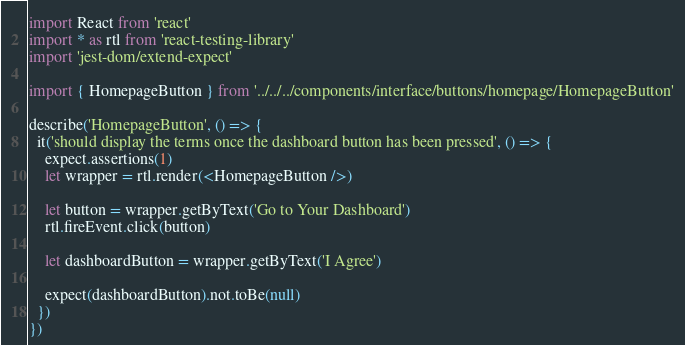Convert code to text. <code><loc_0><loc_0><loc_500><loc_500><_JavaScript_>import React from 'react'
import * as rtl from 'react-testing-library'
import 'jest-dom/extend-expect'

import { HomepageButton } from '../../../components/interface/buttons/homepage/HomepageButton'

describe('HomepageButton', () => {
  it('should display the terms once the dashboard button has been pressed', () => {
    expect.assertions(1)
    let wrapper = rtl.render(<HomepageButton />)

    let button = wrapper.getByText('Go to Your Dashboard')
    rtl.fireEvent.click(button)

    let dashboardButton = wrapper.getByText('I Agree')

    expect(dashboardButton).not.toBe(null)
  })
})
</code> 